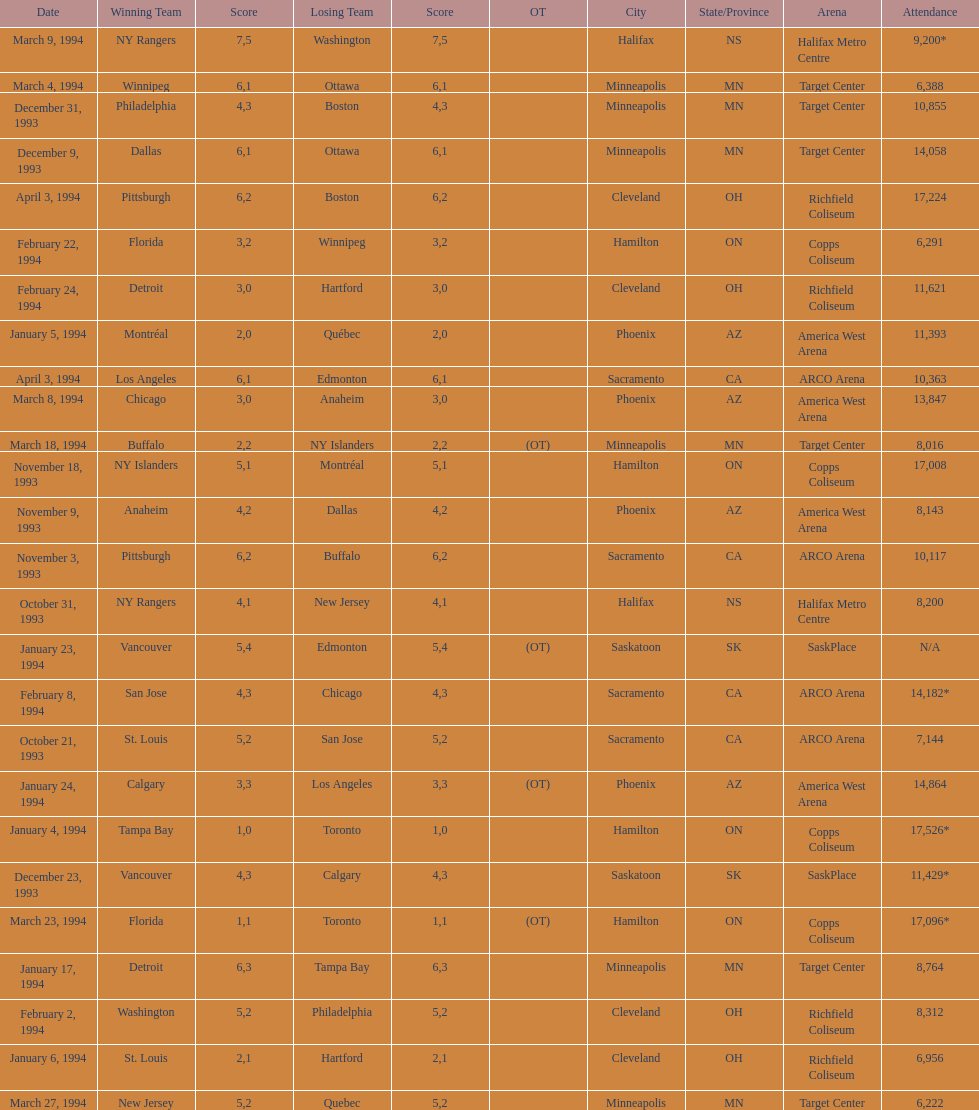How many games have been held in minneapolis? 6. 